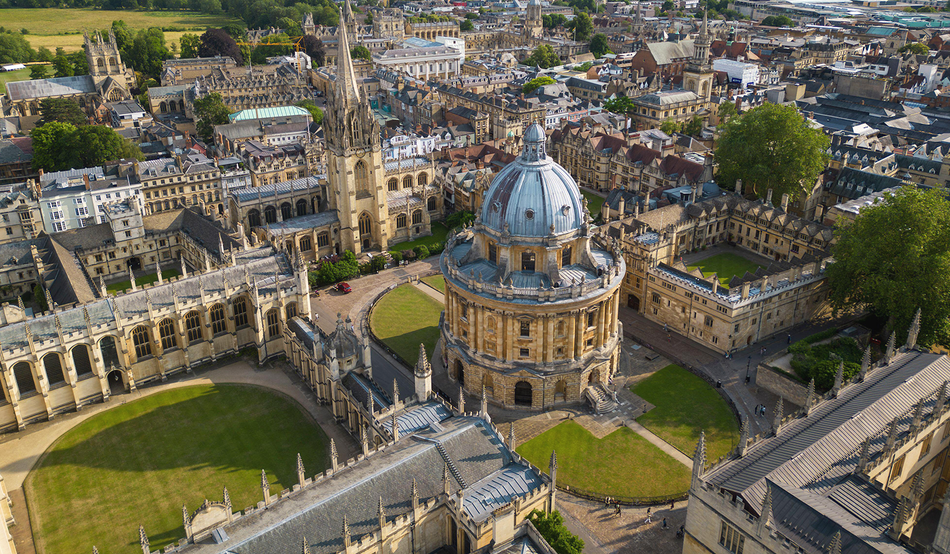Can you tell me more about the history of the structure in the center? Certainly! The Radcliffe Camera, standing proudly at the center, was built between 1737 and 1749 to house the Radcliffe Science Library. Named after physician John Radcliffe, its design was created by architect James Gibbs and has since become an iconic symbol of Oxford. The structure's neoclassical style and its circular plan add to its distinction among the university's predominantly gothic architecture. 